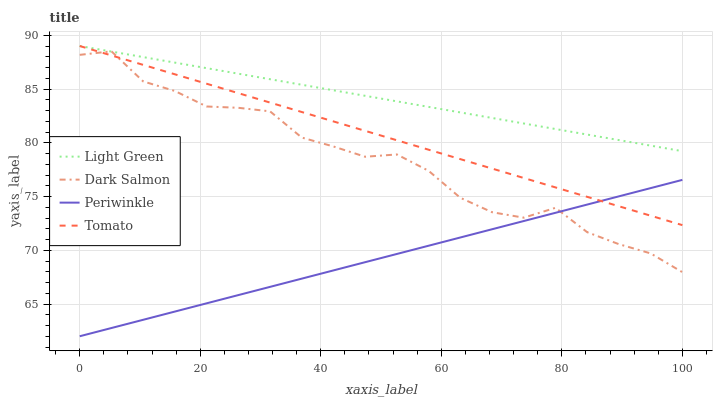Does Periwinkle have the minimum area under the curve?
Answer yes or no. Yes. Does Light Green have the maximum area under the curve?
Answer yes or no. Yes. Does Dark Salmon have the minimum area under the curve?
Answer yes or no. No. Does Dark Salmon have the maximum area under the curve?
Answer yes or no. No. Is Periwinkle the smoothest?
Answer yes or no. Yes. Is Dark Salmon the roughest?
Answer yes or no. Yes. Is Dark Salmon the smoothest?
Answer yes or no. No. Is Periwinkle the roughest?
Answer yes or no. No. Does Periwinkle have the lowest value?
Answer yes or no. Yes. Does Dark Salmon have the lowest value?
Answer yes or no. No. Does Light Green have the highest value?
Answer yes or no. Yes. Does Dark Salmon have the highest value?
Answer yes or no. No. Is Periwinkle less than Light Green?
Answer yes or no. Yes. Is Light Green greater than Periwinkle?
Answer yes or no. Yes. Does Tomato intersect Dark Salmon?
Answer yes or no. Yes. Is Tomato less than Dark Salmon?
Answer yes or no. No. Is Tomato greater than Dark Salmon?
Answer yes or no. No. Does Periwinkle intersect Light Green?
Answer yes or no. No. 